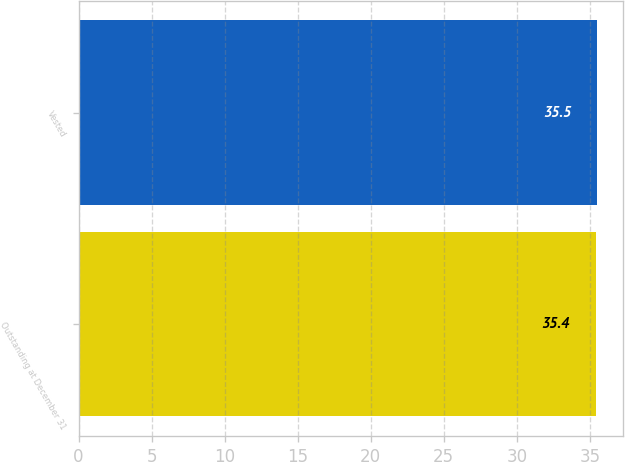Convert chart to OTSL. <chart><loc_0><loc_0><loc_500><loc_500><bar_chart><fcel>Outstanding at December 31<fcel>Vested<nl><fcel>35.4<fcel>35.5<nl></chart> 